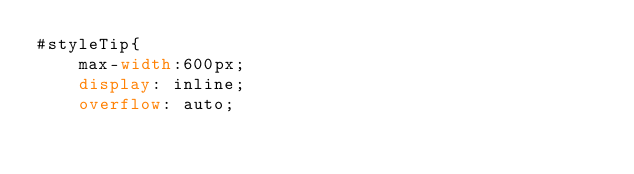Convert code to text. <code><loc_0><loc_0><loc_500><loc_500><_CSS_>#styleTip{
    max-width:600px;
    display: inline;
    overflow: auto;</code> 